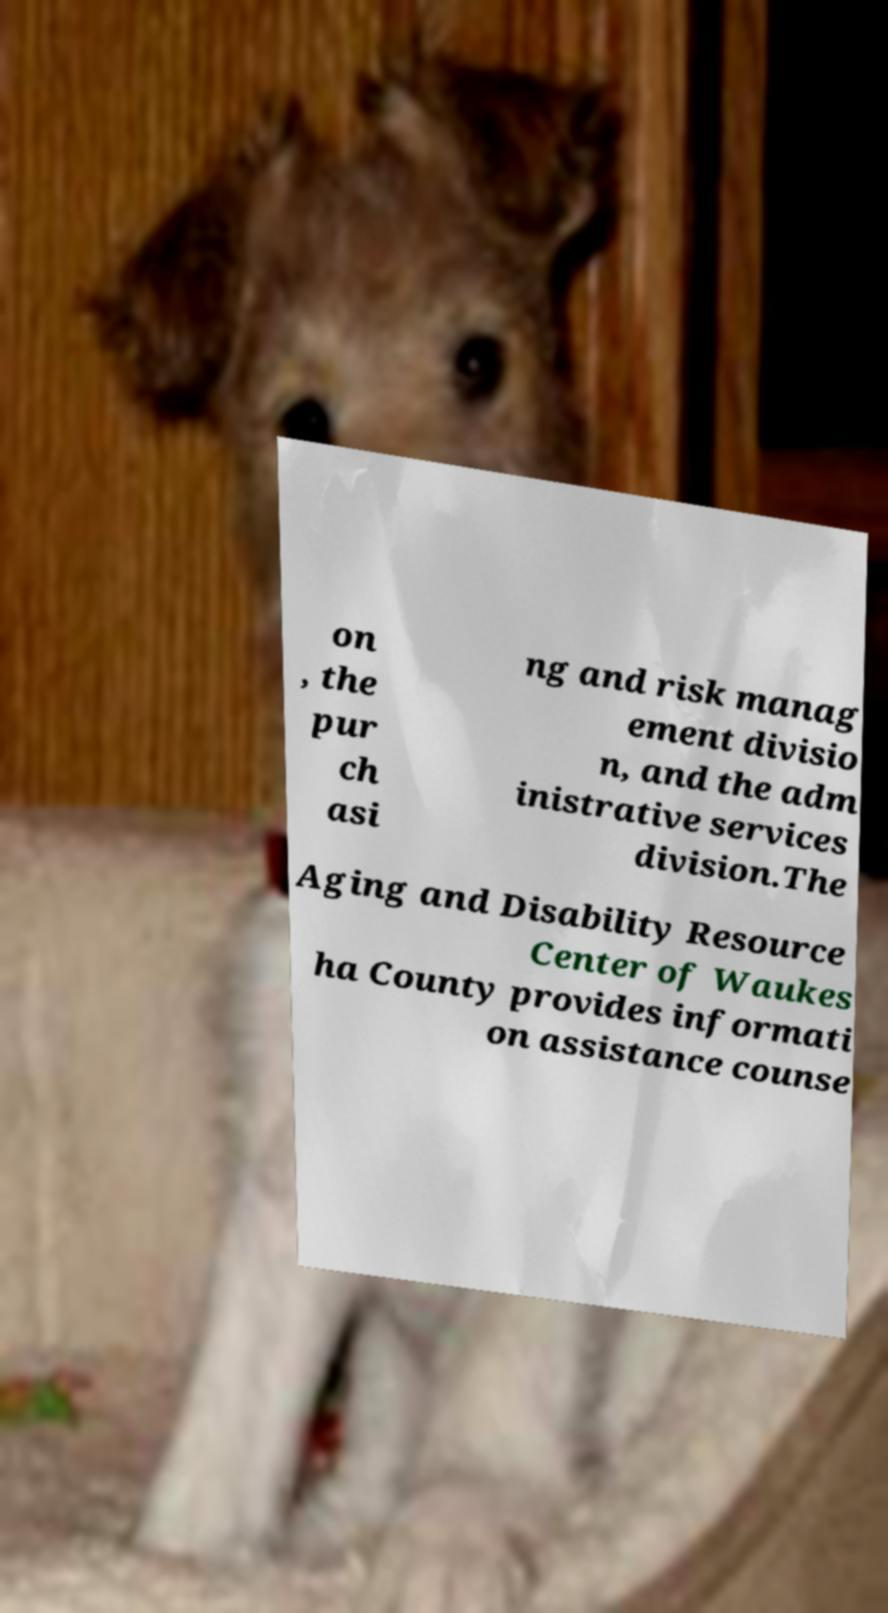I need the written content from this picture converted into text. Can you do that? on , the pur ch asi ng and risk manag ement divisio n, and the adm inistrative services division.The Aging and Disability Resource Center of Waukes ha County provides informati on assistance counse 